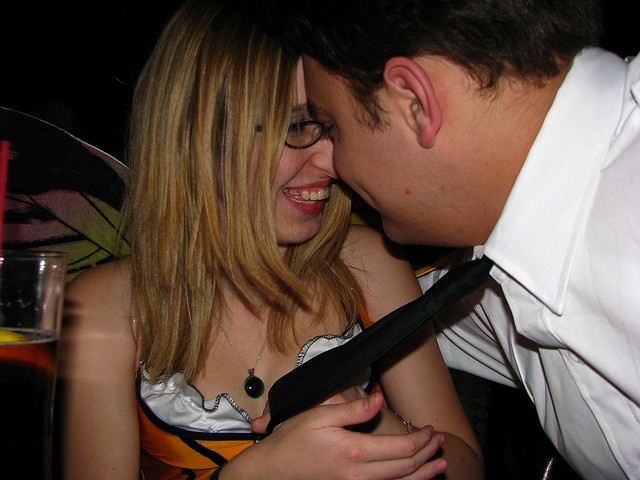Describe the objects in this image and their specific colors. I can see people in black, maroon, and brown tones, people in black, lightgray, brown, and darkgray tones, cup in black, maroon, and gray tones, and tie in black, maroon, and gray tones in this image. 